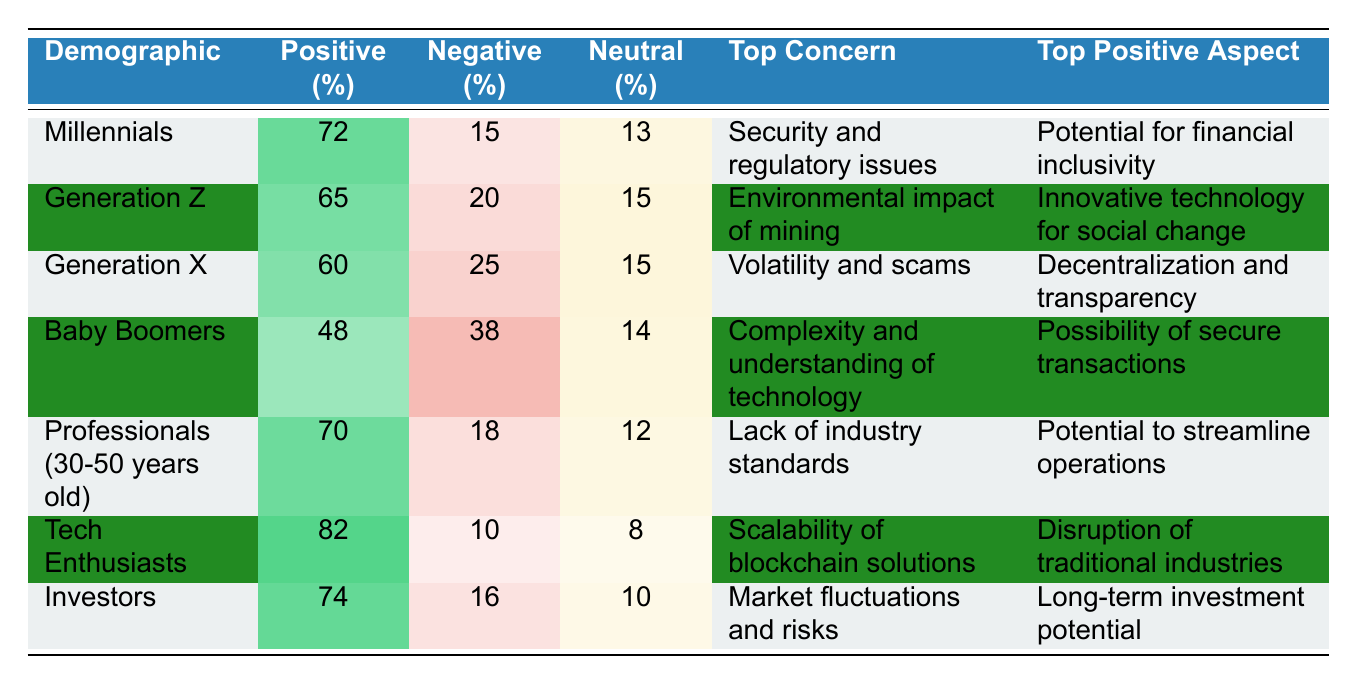What percentage of Baby Boomers have a positive perception of blockchain technology? The table shows that Baby Boomers have a positive perception percentage of 48% listed under the "Positive (%)" column.
Answer: 48% Which demographic has the highest positive perception of blockchain technology? Among all demographics, Tech Enthusiasts have the highest positive perception at 82%, as indicated in the "Positive (%)" column.
Answer: Tech Enthusiasts What is the top concern for Generation Z regarding blockchain technology? The table specifies that Generation Z's top concern is the "Environmental impact of mining."
Answer: Environmental impact of mining What is the difference in positive perception percentage between Millennials and Generation X? Millennials have a positive perception of 72%, while Generation X has 60%. The difference is calculated as 72% - 60% = 12%.
Answer: 12% Are there more people with a negative perception of blockchain among Baby Boomers or Generation X? Baby Boomers have a negative perception of 38%, whereas Generation X has 25%. Since 38% is greater than 25%, Baby Boomers have more negative perception.
Answer: Yes, Baby Boomers What is the average positive perception percentage across all demographics? To find the average, sum all the positive percentages: 72 + 65 + 60 + 48 + 70 + 82 + 74 = 471. There are 7 demographics, so the average is 471 / 7 ≈ 67.29%.
Answer: Approximately 67.29% If you were to group the demographics based on their positive perception, which groups would you identify as high (above 70%) and moderate (50-70%)? Tech Enthusiasts (82%), Investors (74%), Millennials (72%) fall into the high group, while Generation X (60%), Professionals (30-50 years old) (70%), Generation Z (65%) are moderate.
Answer: High: Tech Enthusiasts, Investors, Millennials; Moderate: Generation X, Professionals, Generation Z Which demographic shows the lowest positive perception of blockchain technology alongside their top positive aspect? The demographic with the lowest positive perception is Baby Boomers at 48%, and their top positive aspect is the "Possibility of secure transactions."
Answer: Baby Boomers; Possibility of secure transactions What can we infer about the perception of blockchain technology among Tech Enthusiasts compared to Baby Boomers? Tech Enthusiasts have a significantly higher positive perception of 82% versus Baby Boomers' 48%, indicating that Tech Enthusiasts are generally more optimistic about blockchain technology than Baby Boomers.
Answer: Tech Enthusiasts are more optimistic than Baby Boomers 